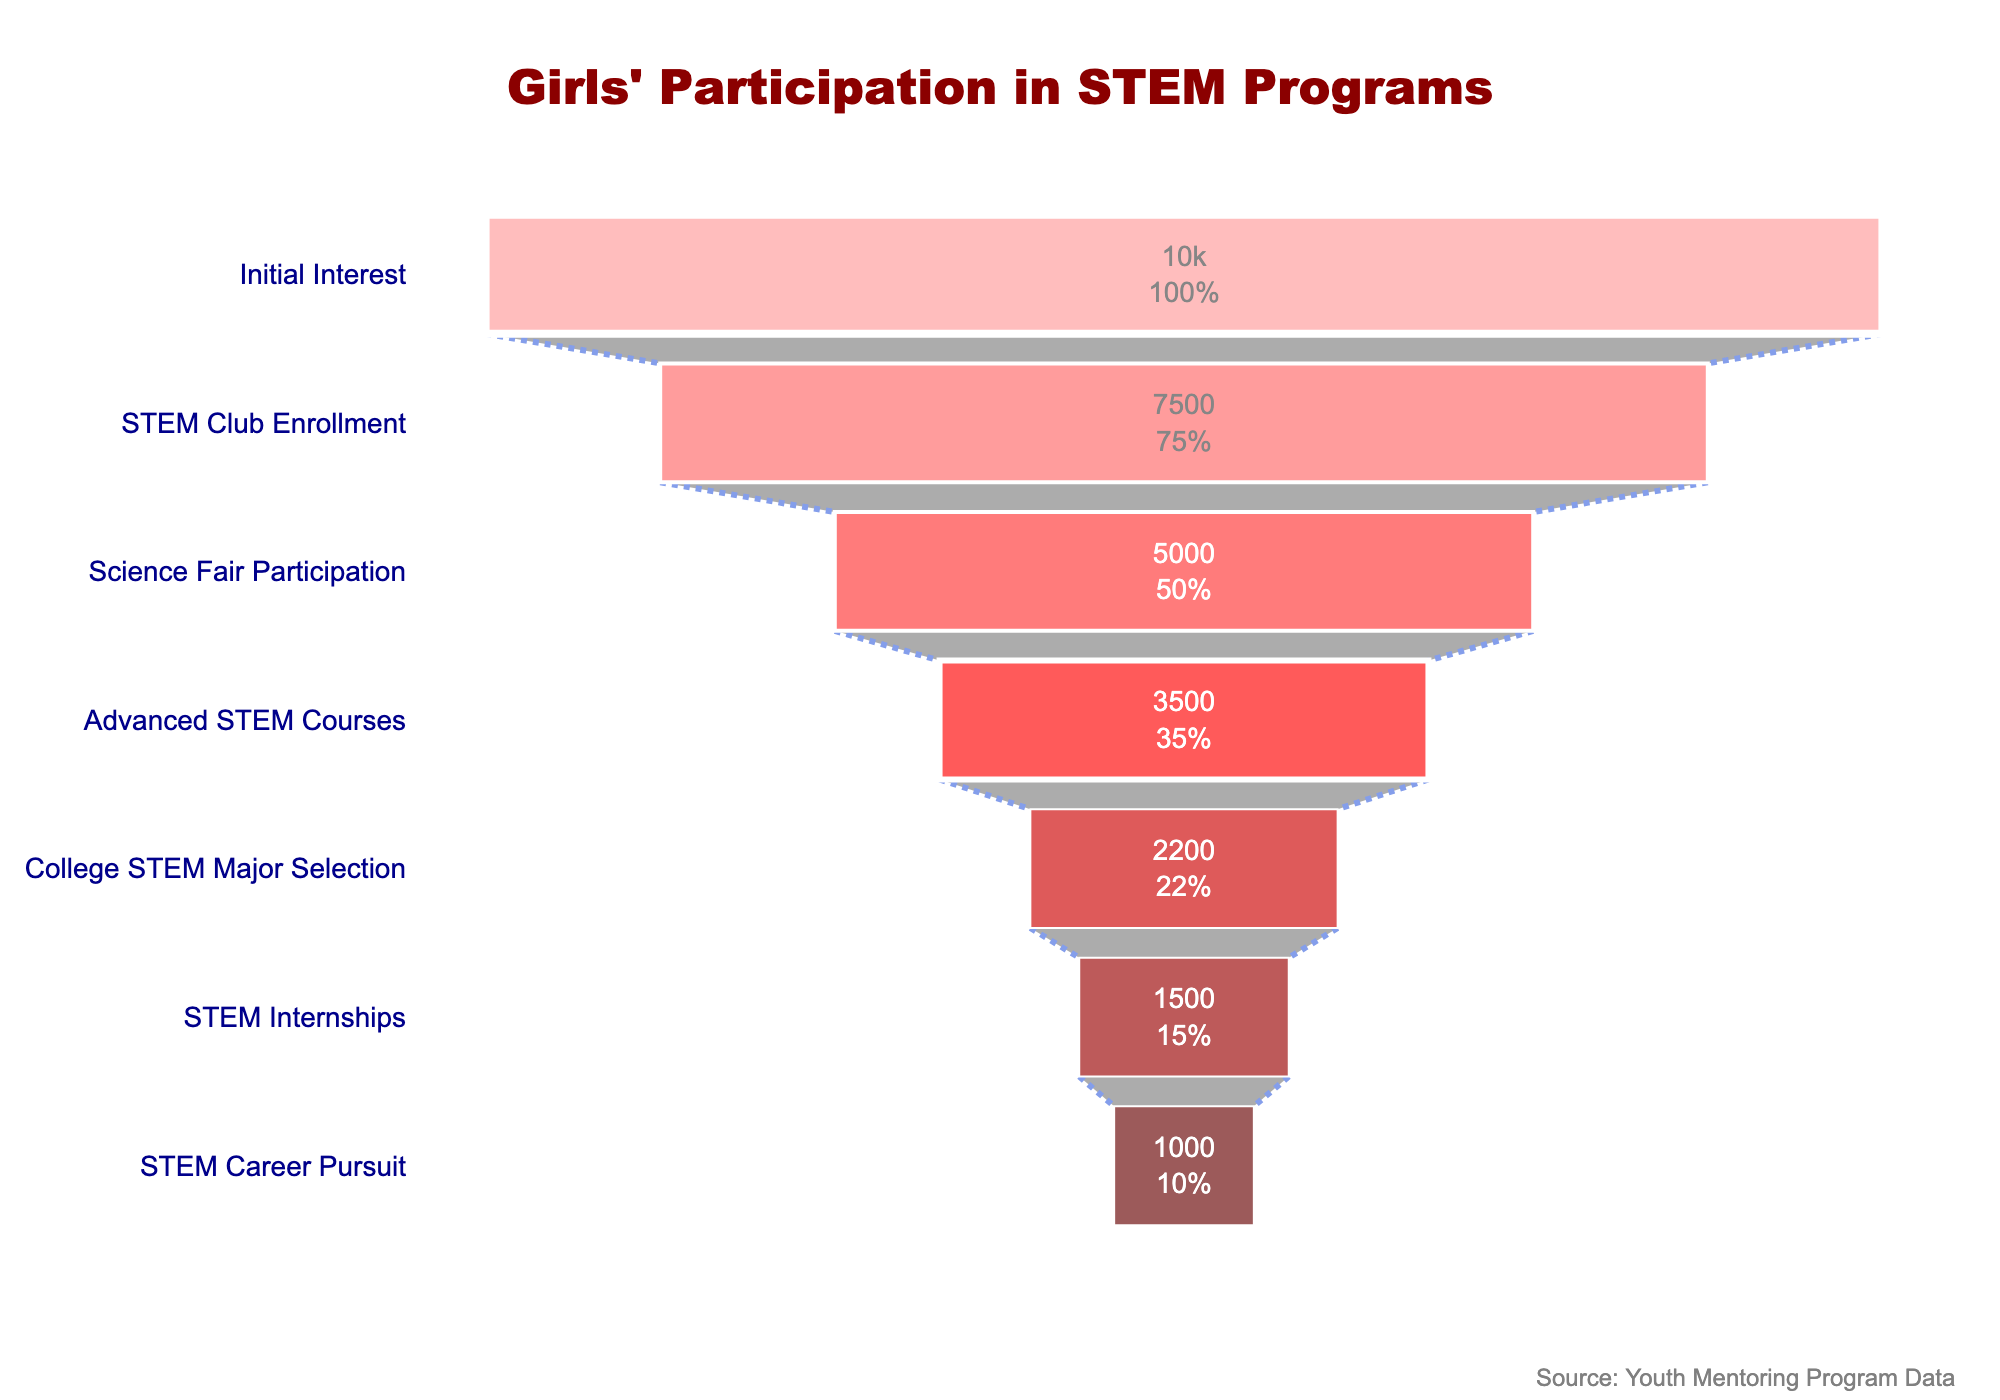How many participants expressed initial interest in STEM programs? The figure shows the number of participants at each stage, and the first stage labeled "Initial Interest" has a participant count.
Answer: 10000 What percentage of participants enrolled in STEM clubs from the initial interest stage? From the figure, the "STEM Club Enrollment" stage shows both the total number of participants and the percentage relative to the initial interest. The percentage can be read directly from the chart.
Answer: 75% What is the difference in the number of participants between STEM Club Enrollment and Science Fair Participation stages? Subtract the number of participants in "Science Fair Participation" (5000) from "STEM Club Enrollment" (7500).
Answer: 2500 How many stages are represented in the funnel chart? Count the number of distinct stages shown in the funnel chart from top to bottom.
Answer: 7 Which stage has the largest decrease in participants compared to the previous stage? Identify the stage with the highest numerical difference between it and the prior stage by subtracting participant counts stage-by-stage. The largest decrease is from "College STEM Major Selection" (2200) to "STEM Internships" (1500).
Answer: STEM Internships What percentage of participants in Advanced STEM Courses pursue a STEM career? Divide the number of participants in "STEM Career Pursuit" (1000) by "Advanced STEM Courses" (3500) and multiply by 100 to get the percentage.
Answer: 28.57% How many more participants major in college STEM fields than those who take STEM internships? Subtract the number of participants in "STEM Internships" (1500) from "College STEM Major Selection" (2200).
Answer: 700 Which stage immediately follows Science Fair Participation? Identify the stage listed directly below "Science Fair Participation" in the funnel chart.
Answer: Advanced STEM Courses What trend can be observed in the number of participants as they progress through the stages? Describe the overall pattern seen in the funnel chart, noting the decrease in participant numbers as they advance from one stage to another.
Answer: Decreasing trend What is the final percentage of participants pursuing a STEM career out of those with initial interest? The final stage "STEM Career Pursuit" shows the percentage relative to the initial interest stage, which can be read directly from the chart.
Answer: 10% 